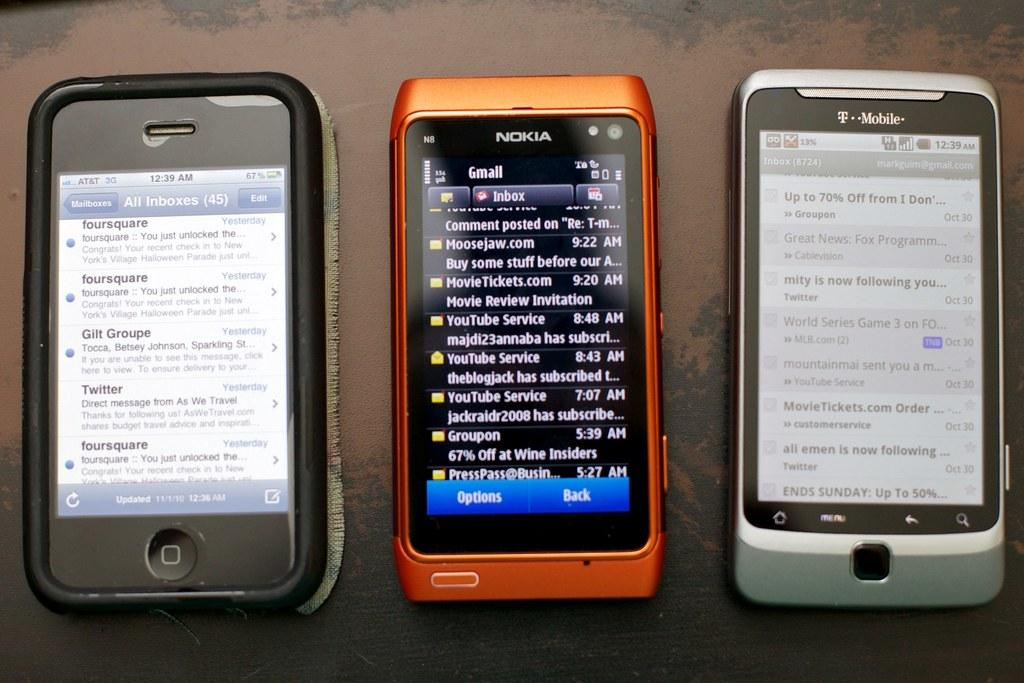<image>
Present a compact description of the photo's key features. Three devices sit in a row one by Nokia and another by T-mobile. 